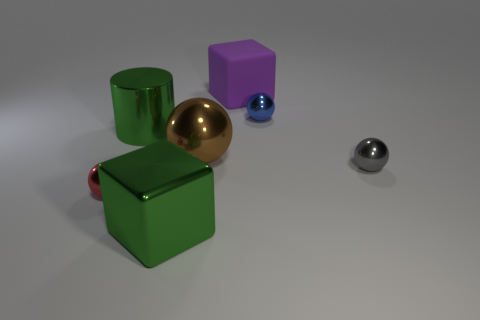Subtract 1 balls. How many balls are left? 3 Subtract all blue balls. How many balls are left? 3 Add 1 spheres. How many objects exist? 8 Subtract all blocks. How many objects are left? 5 Add 5 large green spheres. How many large green spheres exist? 5 Subtract 0 cyan cylinders. How many objects are left? 7 Subtract all blue objects. Subtract all tiny green cylinders. How many objects are left? 6 Add 6 tiny shiny spheres. How many tiny shiny spheres are left? 9 